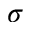<formula> <loc_0><loc_0><loc_500><loc_500>\sigma</formula> 